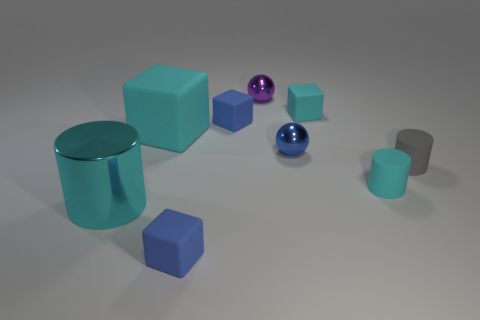What is the shape of the big matte thing that is the same color as the metallic cylinder?
Offer a very short reply. Cube. Is there another tiny cylinder that has the same color as the shiny cylinder?
Your answer should be compact. Yes. What number of objects are cyan cylinders to the right of the purple metallic ball or large red matte spheres?
Keep it short and to the point. 1. How many other objects are the same size as the purple thing?
Make the answer very short. 6. The sphere in front of the small blue rubber block that is on the right side of the small rubber cube that is in front of the small cyan cylinder is made of what material?
Offer a terse response. Metal. How many cylinders are matte objects or tiny matte objects?
Make the answer very short. 2. Are there any other things that are the same shape as the small blue metal object?
Give a very brief answer. Yes. Are there more large cylinders that are on the right side of the big cyan shiny thing than balls that are in front of the small blue shiny object?
Give a very brief answer. No. What number of big matte things are on the right side of the blue rubber object that is in front of the small cyan cylinder?
Offer a terse response. 0. How many things are tiny matte cylinders or large cyan cubes?
Offer a very short reply. 3. 